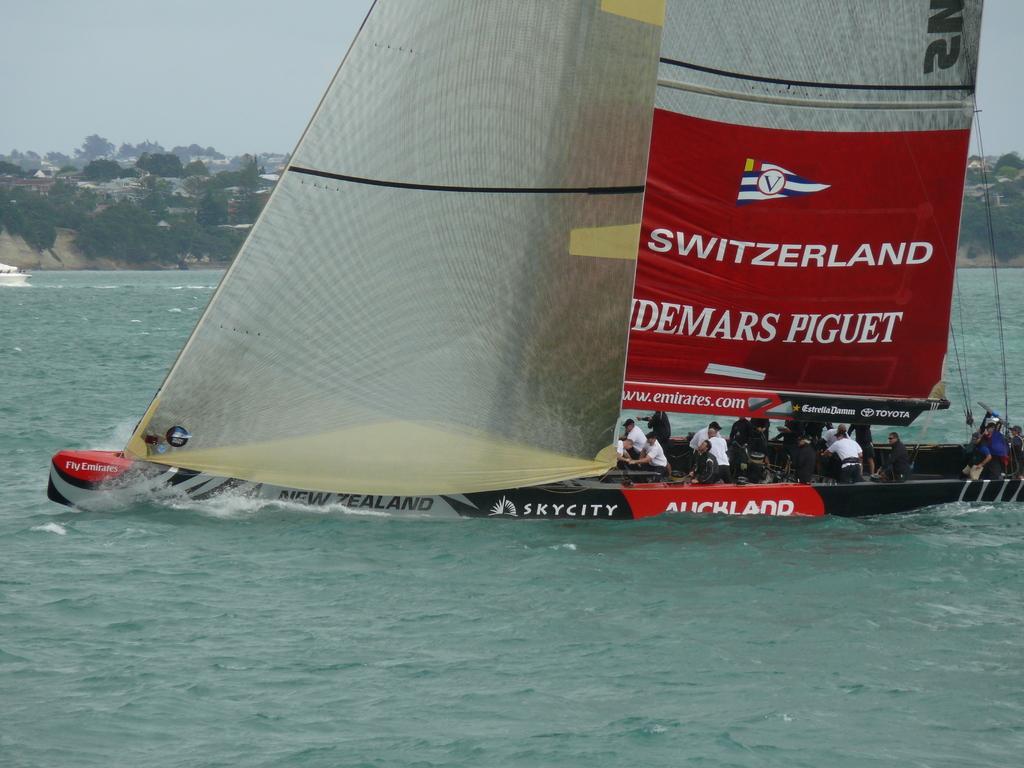Please provide a concise description of this image. In this picture I can see many persons who are standing on the boat. Beside them I can see the cloth and ropes. At the bottom I can see the water flow. In the background I can see the mountains, trees and buildings. In the top left I can see the sky. On the left there is a white color board on the water. 